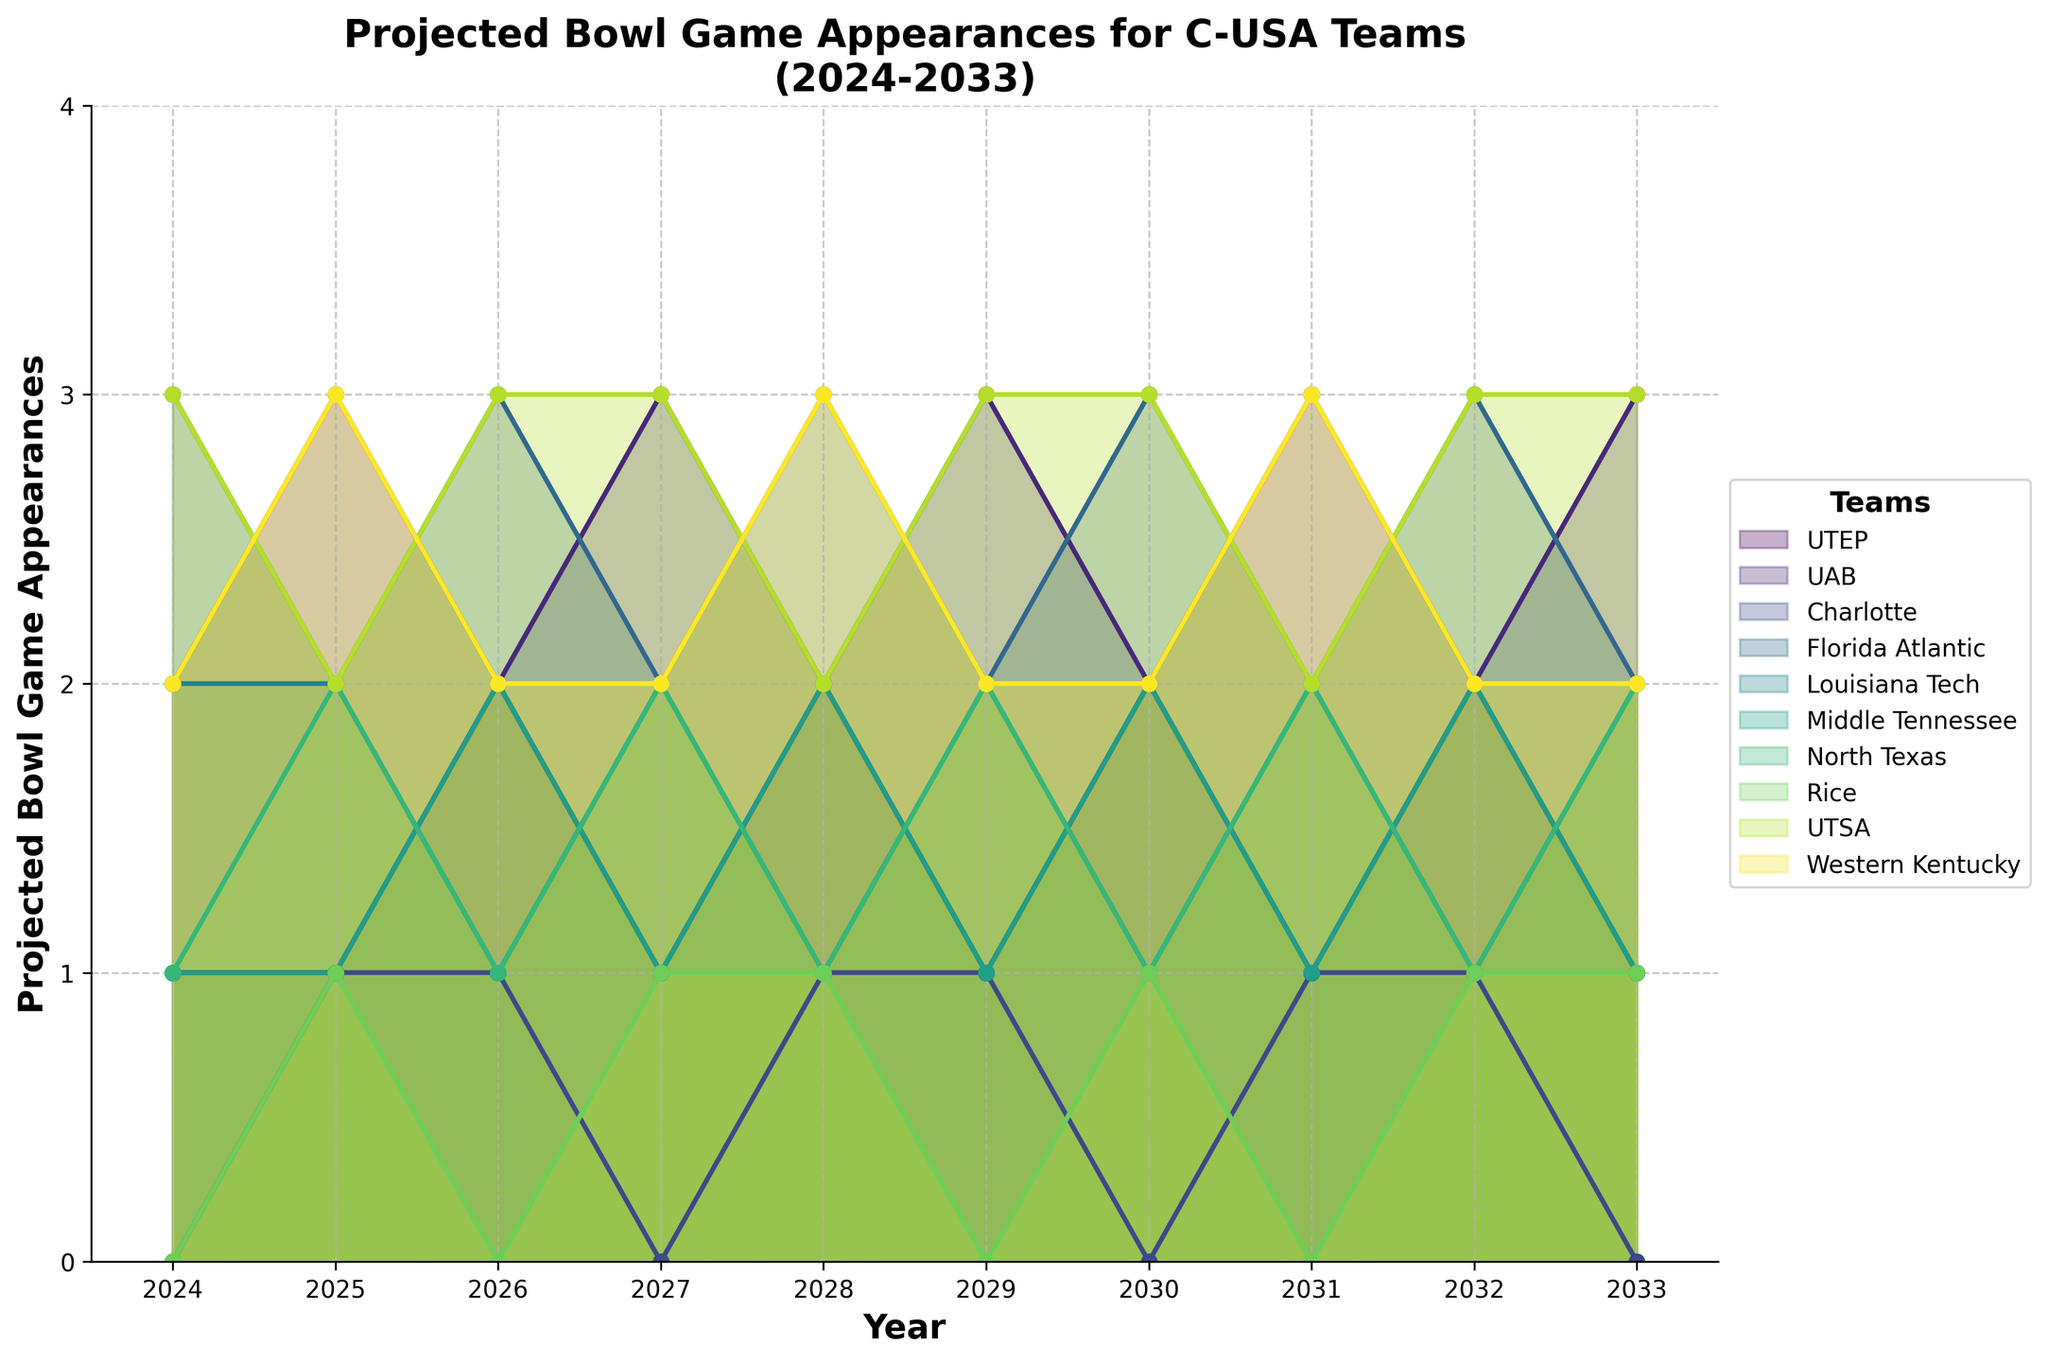What is the title of the figure? The title of the figure is located at the top of the plot, providing an overview of the chart's content.
Answer: Projected Bowl Game Appearances for C-USA Teams (2024-2033) Which years are included on the x-axis? The x-axis labels represent the years spanning the timeline of the projections.
Answer: 2024 to 2033 How many bowl game appearances is UTEP projected to make in 2026? UTEP's projected bowl game appearances for each year are shown along the y-axis, and in 2026, the value is at the position corresponding to UTEP.
Answer: 2 Which team has the highest projected bowl game appearances in 2029? By comparing the y-axis values of all teams for the year 2029, the highest value can be identified.
Answer: UTSA How many total bowl game appearances are projected for UAB over the entire period? Summing up the projected bowl game appearances for UAB from 2024 to 2033. Adding values: 2+3+2+3+2+3+2+3+2+3 = 25.
Answer: 25 In which year does Rice have zero projected bowl game appearances? By examining the data points for Rice across all years, identify the year where the value is zero.
Answer: 2029 What is the average number of projected bowl game appearances for Western Kentucky from 2024 to 2033? Summing the values for Western Kentucky (2+3+2+2+3+2+2+3+2+2=23) and dividing by the number of years (10).
Answer: 2.3 Between UTEP and North Texas, which team has more bowl game appearances in 2027? Compare the y-axis values for UTEP and North Texas in the year 2027; UTEP has 1 and North Texas has 2.
Answer: North Texas How many times does Florida Atlantic make 3 bowl game appearances in a single year? By counting the instances where Florida Atlantic's values reach 3 across all years.
Answer: 5 In 2030, which teams have the same projected number of bowl game appearances? Identify teams with identical y-axis values for the year 2030 and find that Rice and Middle Tennessee both have 2.
Answer: Rice and Middle Tennessee 